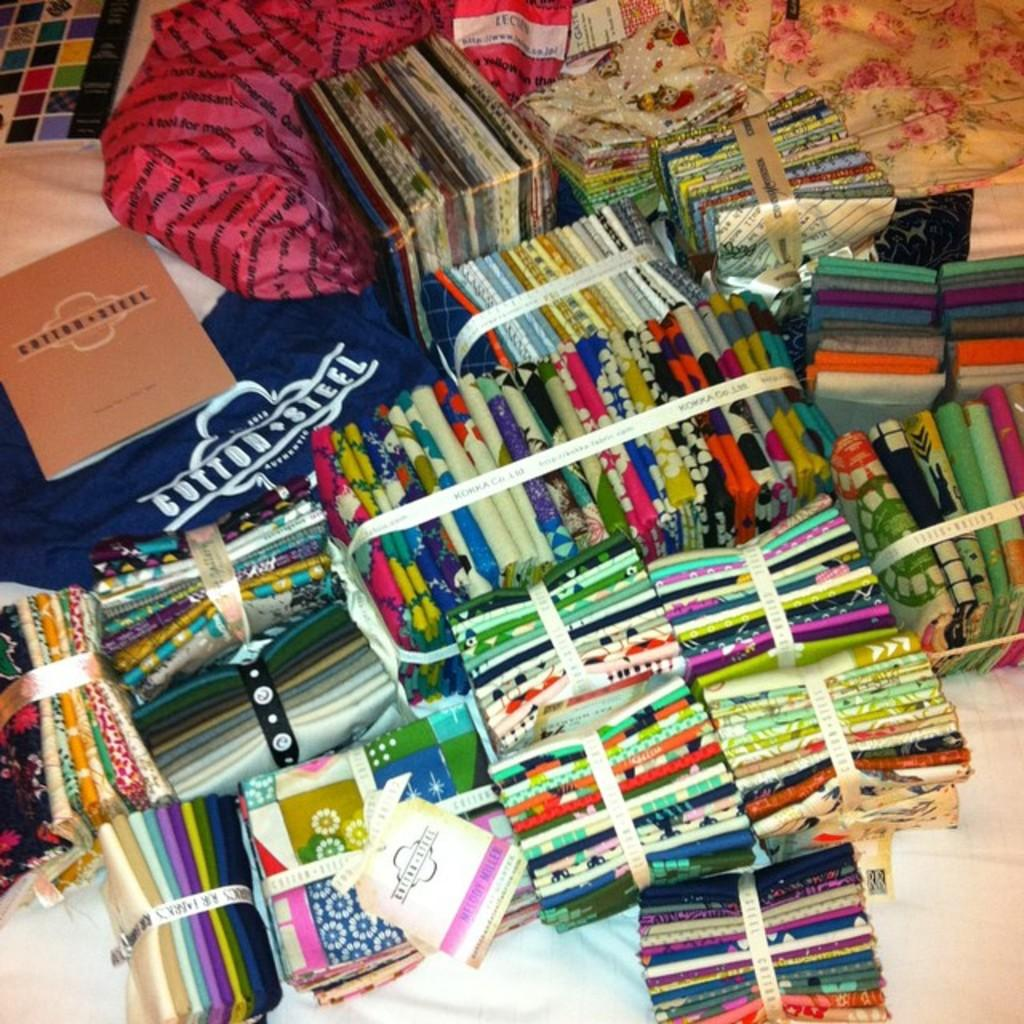<image>
Create a compact narrative representing the image presented. A book titled " Cotton Steel and a shirt with Cotton Steel on the front. 